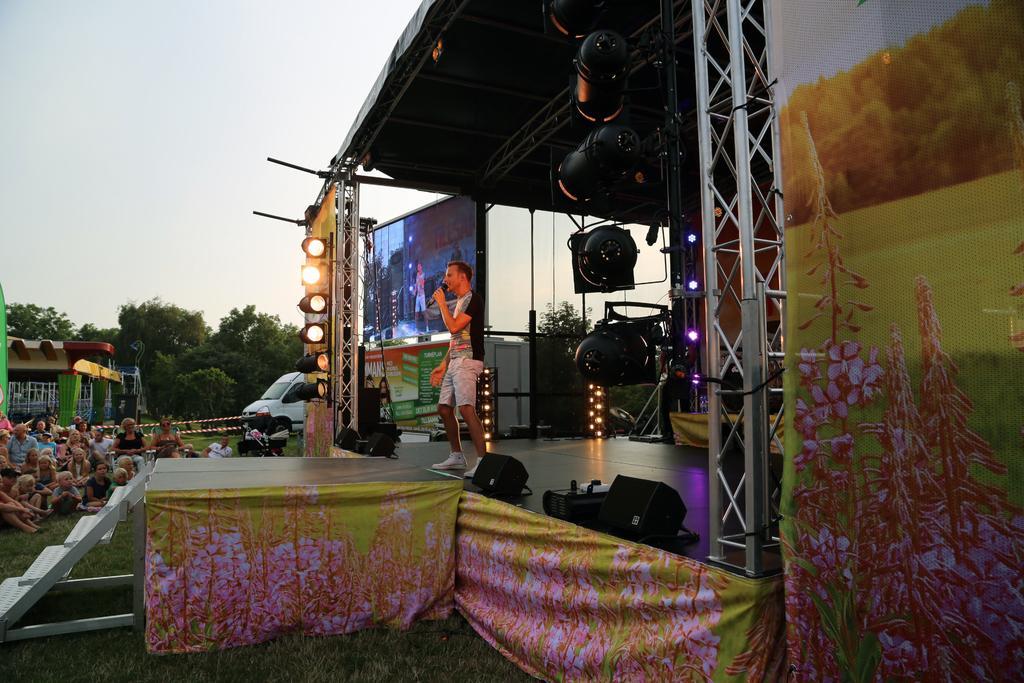In one or two sentences, can you explain what this image depicts? In this picture we can see the sky, trees, a vehicle, poles, caution tapes and the people sitting. On the right side of the picture we can see a man, standing on the platform and he is holding a microphone in the hand. We can see the beams, screen, lights, speakers, designed curtains. At the bottom portion of the picture we can see the green grass and a staircase. We can see few objects. 